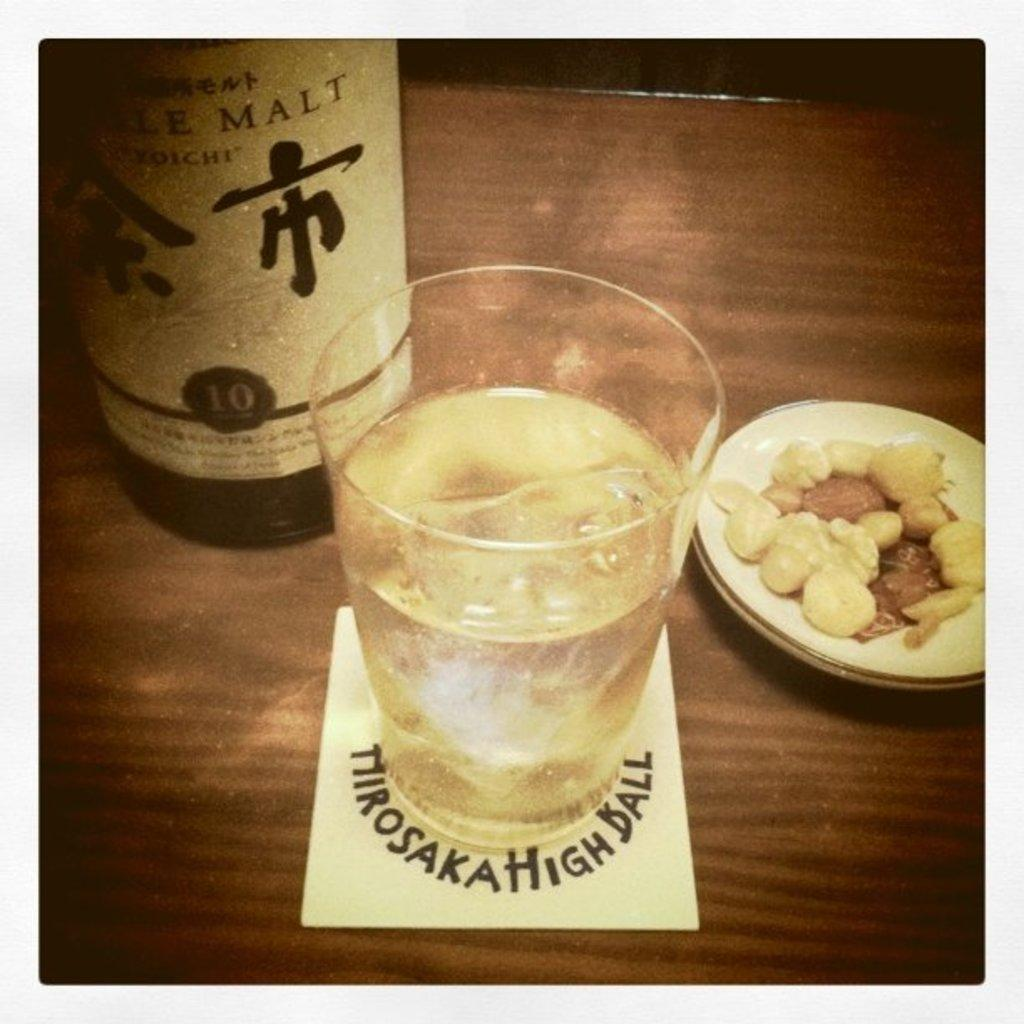<image>
Present a compact description of the photo's key features. A bottle of liqueur on a bat that says single malt on it. 